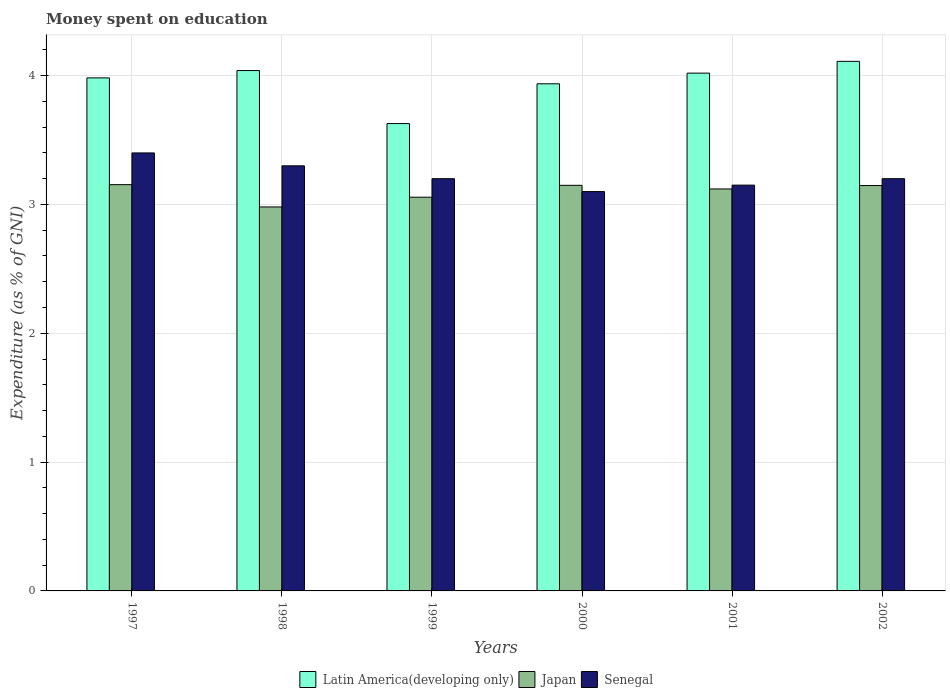How many different coloured bars are there?
Keep it short and to the point. 3. How many groups of bars are there?
Your response must be concise. 6. Are the number of bars per tick equal to the number of legend labels?
Provide a succinct answer. Yes. Are the number of bars on each tick of the X-axis equal?
Offer a terse response. Yes. How many bars are there on the 4th tick from the left?
Offer a very short reply. 3. What is the label of the 3rd group of bars from the left?
Your response must be concise. 1999. In how many cases, is the number of bars for a given year not equal to the number of legend labels?
Keep it short and to the point. 0. Across all years, what is the maximum amount of money spent on education in Senegal?
Ensure brevity in your answer.  3.4. Across all years, what is the minimum amount of money spent on education in Japan?
Provide a succinct answer. 2.98. In which year was the amount of money spent on education in Senegal maximum?
Keep it short and to the point. 1997. In which year was the amount of money spent on education in Senegal minimum?
Your response must be concise. 2000. What is the total amount of money spent on education in Japan in the graph?
Your response must be concise. 18.61. What is the difference between the amount of money spent on education in Latin America(developing only) in 1997 and that in 2001?
Your answer should be very brief. -0.04. What is the difference between the amount of money spent on education in Japan in 2001 and the amount of money spent on education in Latin America(developing only) in 1999?
Offer a very short reply. -0.51. What is the average amount of money spent on education in Latin America(developing only) per year?
Offer a very short reply. 3.95. In the year 1999, what is the difference between the amount of money spent on education in Senegal and amount of money spent on education in Latin America(developing only)?
Keep it short and to the point. -0.43. What is the ratio of the amount of money spent on education in Latin America(developing only) in 2000 to that in 2001?
Offer a terse response. 0.98. Is the amount of money spent on education in Senegal in 1999 less than that in 2000?
Your answer should be very brief. No. Is the difference between the amount of money spent on education in Senegal in 1997 and 1999 greater than the difference between the amount of money spent on education in Latin America(developing only) in 1997 and 1999?
Offer a very short reply. No. What is the difference between the highest and the second highest amount of money spent on education in Latin America(developing only)?
Offer a terse response. 0.07. What is the difference between the highest and the lowest amount of money spent on education in Japan?
Your answer should be very brief. 0.17. In how many years, is the amount of money spent on education in Japan greater than the average amount of money spent on education in Japan taken over all years?
Offer a very short reply. 4. Is the sum of the amount of money spent on education in Japan in 1997 and 2000 greater than the maximum amount of money spent on education in Senegal across all years?
Provide a succinct answer. Yes. What does the 1st bar from the left in 1999 represents?
Offer a very short reply. Latin America(developing only). What does the 3rd bar from the right in 1998 represents?
Offer a terse response. Latin America(developing only). Is it the case that in every year, the sum of the amount of money spent on education in Japan and amount of money spent on education in Latin America(developing only) is greater than the amount of money spent on education in Senegal?
Your answer should be very brief. Yes. How many bars are there?
Offer a terse response. 18. How many legend labels are there?
Offer a terse response. 3. How are the legend labels stacked?
Offer a terse response. Horizontal. What is the title of the graph?
Keep it short and to the point. Money spent on education. What is the label or title of the Y-axis?
Keep it short and to the point. Expenditure (as % of GNI). What is the Expenditure (as % of GNI) in Latin America(developing only) in 1997?
Offer a very short reply. 3.98. What is the Expenditure (as % of GNI) in Japan in 1997?
Offer a terse response. 3.15. What is the Expenditure (as % of GNI) of Senegal in 1997?
Your answer should be compact. 3.4. What is the Expenditure (as % of GNI) in Latin America(developing only) in 1998?
Give a very brief answer. 4.04. What is the Expenditure (as % of GNI) of Japan in 1998?
Make the answer very short. 2.98. What is the Expenditure (as % of GNI) in Senegal in 1998?
Ensure brevity in your answer.  3.3. What is the Expenditure (as % of GNI) in Latin America(developing only) in 1999?
Offer a very short reply. 3.63. What is the Expenditure (as % of GNI) in Japan in 1999?
Provide a succinct answer. 3.06. What is the Expenditure (as % of GNI) in Senegal in 1999?
Your response must be concise. 3.2. What is the Expenditure (as % of GNI) in Latin America(developing only) in 2000?
Your response must be concise. 3.94. What is the Expenditure (as % of GNI) in Japan in 2000?
Your response must be concise. 3.15. What is the Expenditure (as % of GNI) of Senegal in 2000?
Your answer should be very brief. 3.1. What is the Expenditure (as % of GNI) of Latin America(developing only) in 2001?
Make the answer very short. 4.02. What is the Expenditure (as % of GNI) in Japan in 2001?
Make the answer very short. 3.12. What is the Expenditure (as % of GNI) in Senegal in 2001?
Provide a short and direct response. 3.15. What is the Expenditure (as % of GNI) in Latin America(developing only) in 2002?
Keep it short and to the point. 4.11. What is the Expenditure (as % of GNI) of Japan in 2002?
Your response must be concise. 3.15. Across all years, what is the maximum Expenditure (as % of GNI) of Latin America(developing only)?
Provide a short and direct response. 4.11. Across all years, what is the maximum Expenditure (as % of GNI) of Japan?
Ensure brevity in your answer.  3.15. Across all years, what is the maximum Expenditure (as % of GNI) of Senegal?
Your answer should be very brief. 3.4. Across all years, what is the minimum Expenditure (as % of GNI) of Latin America(developing only)?
Your answer should be very brief. 3.63. Across all years, what is the minimum Expenditure (as % of GNI) of Japan?
Your answer should be compact. 2.98. What is the total Expenditure (as % of GNI) in Latin America(developing only) in the graph?
Give a very brief answer. 23.72. What is the total Expenditure (as % of GNI) in Japan in the graph?
Your answer should be very brief. 18.61. What is the total Expenditure (as % of GNI) of Senegal in the graph?
Your answer should be compact. 19.35. What is the difference between the Expenditure (as % of GNI) in Latin America(developing only) in 1997 and that in 1998?
Your response must be concise. -0.06. What is the difference between the Expenditure (as % of GNI) of Japan in 1997 and that in 1998?
Offer a very short reply. 0.17. What is the difference between the Expenditure (as % of GNI) in Latin America(developing only) in 1997 and that in 1999?
Keep it short and to the point. 0.35. What is the difference between the Expenditure (as % of GNI) in Japan in 1997 and that in 1999?
Ensure brevity in your answer.  0.1. What is the difference between the Expenditure (as % of GNI) of Senegal in 1997 and that in 1999?
Provide a succinct answer. 0.2. What is the difference between the Expenditure (as % of GNI) in Latin America(developing only) in 1997 and that in 2000?
Ensure brevity in your answer.  0.05. What is the difference between the Expenditure (as % of GNI) in Japan in 1997 and that in 2000?
Offer a very short reply. 0.01. What is the difference between the Expenditure (as % of GNI) of Latin America(developing only) in 1997 and that in 2001?
Make the answer very short. -0.04. What is the difference between the Expenditure (as % of GNI) in Japan in 1997 and that in 2001?
Keep it short and to the point. 0.03. What is the difference between the Expenditure (as % of GNI) in Latin America(developing only) in 1997 and that in 2002?
Make the answer very short. -0.13. What is the difference between the Expenditure (as % of GNI) of Japan in 1997 and that in 2002?
Make the answer very short. 0.01. What is the difference between the Expenditure (as % of GNI) in Latin America(developing only) in 1998 and that in 1999?
Give a very brief answer. 0.41. What is the difference between the Expenditure (as % of GNI) of Japan in 1998 and that in 1999?
Make the answer very short. -0.08. What is the difference between the Expenditure (as % of GNI) of Latin America(developing only) in 1998 and that in 2000?
Offer a terse response. 0.1. What is the difference between the Expenditure (as % of GNI) of Japan in 1998 and that in 2000?
Offer a very short reply. -0.17. What is the difference between the Expenditure (as % of GNI) in Senegal in 1998 and that in 2000?
Give a very brief answer. 0.2. What is the difference between the Expenditure (as % of GNI) of Japan in 1998 and that in 2001?
Your response must be concise. -0.14. What is the difference between the Expenditure (as % of GNI) in Latin America(developing only) in 1998 and that in 2002?
Your answer should be compact. -0.07. What is the difference between the Expenditure (as % of GNI) of Japan in 1998 and that in 2002?
Your answer should be very brief. -0.17. What is the difference between the Expenditure (as % of GNI) of Latin America(developing only) in 1999 and that in 2000?
Provide a succinct answer. -0.31. What is the difference between the Expenditure (as % of GNI) of Japan in 1999 and that in 2000?
Give a very brief answer. -0.09. What is the difference between the Expenditure (as % of GNI) of Latin America(developing only) in 1999 and that in 2001?
Keep it short and to the point. -0.39. What is the difference between the Expenditure (as % of GNI) in Japan in 1999 and that in 2001?
Ensure brevity in your answer.  -0.06. What is the difference between the Expenditure (as % of GNI) of Senegal in 1999 and that in 2001?
Provide a succinct answer. 0.05. What is the difference between the Expenditure (as % of GNI) in Latin America(developing only) in 1999 and that in 2002?
Your response must be concise. -0.48. What is the difference between the Expenditure (as % of GNI) of Japan in 1999 and that in 2002?
Your answer should be compact. -0.09. What is the difference between the Expenditure (as % of GNI) of Latin America(developing only) in 2000 and that in 2001?
Make the answer very short. -0.08. What is the difference between the Expenditure (as % of GNI) in Japan in 2000 and that in 2001?
Ensure brevity in your answer.  0.03. What is the difference between the Expenditure (as % of GNI) of Latin America(developing only) in 2000 and that in 2002?
Keep it short and to the point. -0.17. What is the difference between the Expenditure (as % of GNI) of Japan in 2000 and that in 2002?
Give a very brief answer. 0. What is the difference between the Expenditure (as % of GNI) of Senegal in 2000 and that in 2002?
Provide a succinct answer. -0.1. What is the difference between the Expenditure (as % of GNI) of Latin America(developing only) in 2001 and that in 2002?
Make the answer very short. -0.09. What is the difference between the Expenditure (as % of GNI) in Japan in 2001 and that in 2002?
Offer a very short reply. -0.03. What is the difference between the Expenditure (as % of GNI) of Senegal in 2001 and that in 2002?
Your response must be concise. -0.05. What is the difference between the Expenditure (as % of GNI) of Latin America(developing only) in 1997 and the Expenditure (as % of GNI) of Japan in 1998?
Give a very brief answer. 1. What is the difference between the Expenditure (as % of GNI) in Latin America(developing only) in 1997 and the Expenditure (as % of GNI) in Senegal in 1998?
Provide a short and direct response. 0.68. What is the difference between the Expenditure (as % of GNI) of Japan in 1997 and the Expenditure (as % of GNI) of Senegal in 1998?
Give a very brief answer. -0.15. What is the difference between the Expenditure (as % of GNI) in Latin America(developing only) in 1997 and the Expenditure (as % of GNI) in Japan in 1999?
Your answer should be very brief. 0.93. What is the difference between the Expenditure (as % of GNI) in Latin America(developing only) in 1997 and the Expenditure (as % of GNI) in Senegal in 1999?
Make the answer very short. 0.78. What is the difference between the Expenditure (as % of GNI) of Japan in 1997 and the Expenditure (as % of GNI) of Senegal in 1999?
Keep it short and to the point. -0.05. What is the difference between the Expenditure (as % of GNI) in Latin America(developing only) in 1997 and the Expenditure (as % of GNI) in Japan in 2000?
Make the answer very short. 0.83. What is the difference between the Expenditure (as % of GNI) in Latin America(developing only) in 1997 and the Expenditure (as % of GNI) in Senegal in 2000?
Your answer should be very brief. 0.88. What is the difference between the Expenditure (as % of GNI) in Japan in 1997 and the Expenditure (as % of GNI) in Senegal in 2000?
Keep it short and to the point. 0.05. What is the difference between the Expenditure (as % of GNI) of Latin America(developing only) in 1997 and the Expenditure (as % of GNI) of Japan in 2001?
Keep it short and to the point. 0.86. What is the difference between the Expenditure (as % of GNI) of Latin America(developing only) in 1997 and the Expenditure (as % of GNI) of Senegal in 2001?
Your response must be concise. 0.83. What is the difference between the Expenditure (as % of GNI) in Japan in 1997 and the Expenditure (as % of GNI) in Senegal in 2001?
Provide a short and direct response. 0. What is the difference between the Expenditure (as % of GNI) of Latin America(developing only) in 1997 and the Expenditure (as % of GNI) of Japan in 2002?
Provide a succinct answer. 0.84. What is the difference between the Expenditure (as % of GNI) in Latin America(developing only) in 1997 and the Expenditure (as % of GNI) in Senegal in 2002?
Your answer should be very brief. 0.78. What is the difference between the Expenditure (as % of GNI) of Japan in 1997 and the Expenditure (as % of GNI) of Senegal in 2002?
Make the answer very short. -0.05. What is the difference between the Expenditure (as % of GNI) in Latin America(developing only) in 1998 and the Expenditure (as % of GNI) in Japan in 1999?
Your answer should be compact. 0.98. What is the difference between the Expenditure (as % of GNI) of Latin America(developing only) in 1998 and the Expenditure (as % of GNI) of Senegal in 1999?
Make the answer very short. 0.84. What is the difference between the Expenditure (as % of GNI) in Japan in 1998 and the Expenditure (as % of GNI) in Senegal in 1999?
Your response must be concise. -0.22. What is the difference between the Expenditure (as % of GNI) in Latin America(developing only) in 1998 and the Expenditure (as % of GNI) in Japan in 2000?
Your answer should be very brief. 0.89. What is the difference between the Expenditure (as % of GNI) of Latin America(developing only) in 1998 and the Expenditure (as % of GNI) of Senegal in 2000?
Your answer should be very brief. 0.94. What is the difference between the Expenditure (as % of GNI) of Japan in 1998 and the Expenditure (as % of GNI) of Senegal in 2000?
Offer a terse response. -0.12. What is the difference between the Expenditure (as % of GNI) in Latin America(developing only) in 1998 and the Expenditure (as % of GNI) in Japan in 2001?
Your response must be concise. 0.92. What is the difference between the Expenditure (as % of GNI) in Latin America(developing only) in 1998 and the Expenditure (as % of GNI) in Senegal in 2001?
Your response must be concise. 0.89. What is the difference between the Expenditure (as % of GNI) of Japan in 1998 and the Expenditure (as % of GNI) of Senegal in 2001?
Provide a short and direct response. -0.17. What is the difference between the Expenditure (as % of GNI) in Latin America(developing only) in 1998 and the Expenditure (as % of GNI) in Japan in 2002?
Your answer should be compact. 0.89. What is the difference between the Expenditure (as % of GNI) of Latin America(developing only) in 1998 and the Expenditure (as % of GNI) of Senegal in 2002?
Your answer should be very brief. 0.84. What is the difference between the Expenditure (as % of GNI) of Japan in 1998 and the Expenditure (as % of GNI) of Senegal in 2002?
Your answer should be compact. -0.22. What is the difference between the Expenditure (as % of GNI) in Latin America(developing only) in 1999 and the Expenditure (as % of GNI) in Japan in 2000?
Offer a terse response. 0.48. What is the difference between the Expenditure (as % of GNI) in Latin America(developing only) in 1999 and the Expenditure (as % of GNI) in Senegal in 2000?
Give a very brief answer. 0.53. What is the difference between the Expenditure (as % of GNI) of Japan in 1999 and the Expenditure (as % of GNI) of Senegal in 2000?
Your answer should be compact. -0.04. What is the difference between the Expenditure (as % of GNI) in Latin America(developing only) in 1999 and the Expenditure (as % of GNI) in Japan in 2001?
Your answer should be compact. 0.51. What is the difference between the Expenditure (as % of GNI) in Latin America(developing only) in 1999 and the Expenditure (as % of GNI) in Senegal in 2001?
Ensure brevity in your answer.  0.48. What is the difference between the Expenditure (as % of GNI) of Japan in 1999 and the Expenditure (as % of GNI) of Senegal in 2001?
Provide a succinct answer. -0.09. What is the difference between the Expenditure (as % of GNI) in Latin America(developing only) in 1999 and the Expenditure (as % of GNI) in Japan in 2002?
Provide a succinct answer. 0.48. What is the difference between the Expenditure (as % of GNI) in Latin America(developing only) in 1999 and the Expenditure (as % of GNI) in Senegal in 2002?
Offer a terse response. 0.43. What is the difference between the Expenditure (as % of GNI) in Japan in 1999 and the Expenditure (as % of GNI) in Senegal in 2002?
Your answer should be compact. -0.14. What is the difference between the Expenditure (as % of GNI) of Latin America(developing only) in 2000 and the Expenditure (as % of GNI) of Japan in 2001?
Your answer should be compact. 0.82. What is the difference between the Expenditure (as % of GNI) of Latin America(developing only) in 2000 and the Expenditure (as % of GNI) of Senegal in 2001?
Provide a short and direct response. 0.79. What is the difference between the Expenditure (as % of GNI) in Japan in 2000 and the Expenditure (as % of GNI) in Senegal in 2001?
Your answer should be compact. -0. What is the difference between the Expenditure (as % of GNI) of Latin America(developing only) in 2000 and the Expenditure (as % of GNI) of Japan in 2002?
Your answer should be compact. 0.79. What is the difference between the Expenditure (as % of GNI) in Latin America(developing only) in 2000 and the Expenditure (as % of GNI) in Senegal in 2002?
Your answer should be compact. 0.74. What is the difference between the Expenditure (as % of GNI) in Japan in 2000 and the Expenditure (as % of GNI) in Senegal in 2002?
Make the answer very short. -0.05. What is the difference between the Expenditure (as % of GNI) of Latin America(developing only) in 2001 and the Expenditure (as % of GNI) of Japan in 2002?
Offer a very short reply. 0.87. What is the difference between the Expenditure (as % of GNI) of Latin America(developing only) in 2001 and the Expenditure (as % of GNI) of Senegal in 2002?
Your answer should be very brief. 0.82. What is the difference between the Expenditure (as % of GNI) in Japan in 2001 and the Expenditure (as % of GNI) in Senegal in 2002?
Your answer should be compact. -0.08. What is the average Expenditure (as % of GNI) in Latin America(developing only) per year?
Give a very brief answer. 3.95. What is the average Expenditure (as % of GNI) in Japan per year?
Give a very brief answer. 3.1. What is the average Expenditure (as % of GNI) of Senegal per year?
Provide a succinct answer. 3.23. In the year 1997, what is the difference between the Expenditure (as % of GNI) of Latin America(developing only) and Expenditure (as % of GNI) of Japan?
Your answer should be compact. 0.83. In the year 1997, what is the difference between the Expenditure (as % of GNI) in Latin America(developing only) and Expenditure (as % of GNI) in Senegal?
Make the answer very short. 0.58. In the year 1997, what is the difference between the Expenditure (as % of GNI) of Japan and Expenditure (as % of GNI) of Senegal?
Your answer should be very brief. -0.25. In the year 1998, what is the difference between the Expenditure (as % of GNI) of Latin America(developing only) and Expenditure (as % of GNI) of Japan?
Provide a succinct answer. 1.06. In the year 1998, what is the difference between the Expenditure (as % of GNI) in Latin America(developing only) and Expenditure (as % of GNI) in Senegal?
Provide a succinct answer. 0.74. In the year 1998, what is the difference between the Expenditure (as % of GNI) of Japan and Expenditure (as % of GNI) of Senegal?
Give a very brief answer. -0.32. In the year 1999, what is the difference between the Expenditure (as % of GNI) in Latin America(developing only) and Expenditure (as % of GNI) in Japan?
Your answer should be compact. 0.57. In the year 1999, what is the difference between the Expenditure (as % of GNI) of Latin America(developing only) and Expenditure (as % of GNI) of Senegal?
Provide a short and direct response. 0.43. In the year 1999, what is the difference between the Expenditure (as % of GNI) of Japan and Expenditure (as % of GNI) of Senegal?
Your answer should be compact. -0.14. In the year 2000, what is the difference between the Expenditure (as % of GNI) in Latin America(developing only) and Expenditure (as % of GNI) in Japan?
Make the answer very short. 0.79. In the year 2000, what is the difference between the Expenditure (as % of GNI) in Latin America(developing only) and Expenditure (as % of GNI) in Senegal?
Your answer should be very brief. 0.84. In the year 2000, what is the difference between the Expenditure (as % of GNI) of Japan and Expenditure (as % of GNI) of Senegal?
Give a very brief answer. 0.05. In the year 2001, what is the difference between the Expenditure (as % of GNI) of Latin America(developing only) and Expenditure (as % of GNI) of Japan?
Offer a very short reply. 0.9. In the year 2001, what is the difference between the Expenditure (as % of GNI) in Latin America(developing only) and Expenditure (as % of GNI) in Senegal?
Your response must be concise. 0.87. In the year 2001, what is the difference between the Expenditure (as % of GNI) of Japan and Expenditure (as % of GNI) of Senegal?
Provide a short and direct response. -0.03. In the year 2002, what is the difference between the Expenditure (as % of GNI) in Latin America(developing only) and Expenditure (as % of GNI) in Japan?
Your response must be concise. 0.96. In the year 2002, what is the difference between the Expenditure (as % of GNI) in Latin America(developing only) and Expenditure (as % of GNI) in Senegal?
Give a very brief answer. 0.91. In the year 2002, what is the difference between the Expenditure (as % of GNI) of Japan and Expenditure (as % of GNI) of Senegal?
Provide a short and direct response. -0.05. What is the ratio of the Expenditure (as % of GNI) of Latin America(developing only) in 1997 to that in 1998?
Make the answer very short. 0.99. What is the ratio of the Expenditure (as % of GNI) in Japan in 1997 to that in 1998?
Ensure brevity in your answer.  1.06. What is the ratio of the Expenditure (as % of GNI) of Senegal in 1997 to that in 1998?
Your answer should be compact. 1.03. What is the ratio of the Expenditure (as % of GNI) of Latin America(developing only) in 1997 to that in 1999?
Offer a very short reply. 1.1. What is the ratio of the Expenditure (as % of GNI) of Japan in 1997 to that in 1999?
Your answer should be compact. 1.03. What is the ratio of the Expenditure (as % of GNI) of Latin America(developing only) in 1997 to that in 2000?
Offer a terse response. 1.01. What is the ratio of the Expenditure (as % of GNI) in Japan in 1997 to that in 2000?
Ensure brevity in your answer.  1. What is the ratio of the Expenditure (as % of GNI) in Senegal in 1997 to that in 2000?
Make the answer very short. 1.1. What is the ratio of the Expenditure (as % of GNI) of Latin America(developing only) in 1997 to that in 2001?
Ensure brevity in your answer.  0.99. What is the ratio of the Expenditure (as % of GNI) in Japan in 1997 to that in 2001?
Offer a terse response. 1.01. What is the ratio of the Expenditure (as % of GNI) of Senegal in 1997 to that in 2001?
Give a very brief answer. 1.08. What is the ratio of the Expenditure (as % of GNI) of Latin America(developing only) in 1997 to that in 2002?
Provide a short and direct response. 0.97. What is the ratio of the Expenditure (as % of GNI) in Japan in 1997 to that in 2002?
Make the answer very short. 1. What is the ratio of the Expenditure (as % of GNI) in Senegal in 1997 to that in 2002?
Give a very brief answer. 1.06. What is the ratio of the Expenditure (as % of GNI) of Latin America(developing only) in 1998 to that in 1999?
Keep it short and to the point. 1.11. What is the ratio of the Expenditure (as % of GNI) of Japan in 1998 to that in 1999?
Give a very brief answer. 0.98. What is the ratio of the Expenditure (as % of GNI) in Senegal in 1998 to that in 1999?
Make the answer very short. 1.03. What is the ratio of the Expenditure (as % of GNI) of Latin America(developing only) in 1998 to that in 2000?
Make the answer very short. 1.03. What is the ratio of the Expenditure (as % of GNI) in Japan in 1998 to that in 2000?
Your answer should be compact. 0.95. What is the ratio of the Expenditure (as % of GNI) of Senegal in 1998 to that in 2000?
Ensure brevity in your answer.  1.06. What is the ratio of the Expenditure (as % of GNI) in Latin America(developing only) in 1998 to that in 2001?
Your answer should be very brief. 1. What is the ratio of the Expenditure (as % of GNI) of Japan in 1998 to that in 2001?
Your answer should be compact. 0.96. What is the ratio of the Expenditure (as % of GNI) in Senegal in 1998 to that in 2001?
Offer a very short reply. 1.05. What is the ratio of the Expenditure (as % of GNI) in Latin America(developing only) in 1998 to that in 2002?
Offer a terse response. 0.98. What is the ratio of the Expenditure (as % of GNI) in Japan in 1998 to that in 2002?
Offer a very short reply. 0.95. What is the ratio of the Expenditure (as % of GNI) in Senegal in 1998 to that in 2002?
Offer a very short reply. 1.03. What is the ratio of the Expenditure (as % of GNI) of Latin America(developing only) in 1999 to that in 2000?
Keep it short and to the point. 0.92. What is the ratio of the Expenditure (as % of GNI) of Japan in 1999 to that in 2000?
Give a very brief answer. 0.97. What is the ratio of the Expenditure (as % of GNI) in Senegal in 1999 to that in 2000?
Provide a short and direct response. 1.03. What is the ratio of the Expenditure (as % of GNI) of Latin America(developing only) in 1999 to that in 2001?
Ensure brevity in your answer.  0.9. What is the ratio of the Expenditure (as % of GNI) in Japan in 1999 to that in 2001?
Provide a short and direct response. 0.98. What is the ratio of the Expenditure (as % of GNI) in Senegal in 1999 to that in 2001?
Your answer should be very brief. 1.02. What is the ratio of the Expenditure (as % of GNI) of Latin America(developing only) in 1999 to that in 2002?
Your answer should be very brief. 0.88. What is the ratio of the Expenditure (as % of GNI) of Japan in 1999 to that in 2002?
Ensure brevity in your answer.  0.97. What is the ratio of the Expenditure (as % of GNI) in Latin America(developing only) in 2000 to that in 2001?
Your response must be concise. 0.98. What is the ratio of the Expenditure (as % of GNI) of Japan in 2000 to that in 2001?
Provide a short and direct response. 1.01. What is the ratio of the Expenditure (as % of GNI) of Senegal in 2000 to that in 2001?
Your answer should be compact. 0.98. What is the ratio of the Expenditure (as % of GNI) in Latin America(developing only) in 2000 to that in 2002?
Provide a succinct answer. 0.96. What is the ratio of the Expenditure (as % of GNI) in Senegal in 2000 to that in 2002?
Offer a very short reply. 0.97. What is the ratio of the Expenditure (as % of GNI) in Latin America(developing only) in 2001 to that in 2002?
Your answer should be very brief. 0.98. What is the ratio of the Expenditure (as % of GNI) in Japan in 2001 to that in 2002?
Keep it short and to the point. 0.99. What is the ratio of the Expenditure (as % of GNI) of Senegal in 2001 to that in 2002?
Provide a short and direct response. 0.98. What is the difference between the highest and the second highest Expenditure (as % of GNI) in Latin America(developing only)?
Your answer should be very brief. 0.07. What is the difference between the highest and the second highest Expenditure (as % of GNI) of Japan?
Offer a very short reply. 0.01. What is the difference between the highest and the lowest Expenditure (as % of GNI) in Latin America(developing only)?
Your answer should be compact. 0.48. What is the difference between the highest and the lowest Expenditure (as % of GNI) in Japan?
Ensure brevity in your answer.  0.17. What is the difference between the highest and the lowest Expenditure (as % of GNI) in Senegal?
Give a very brief answer. 0.3. 